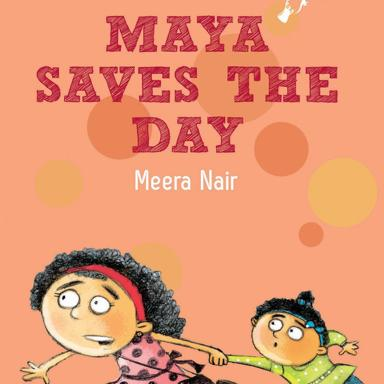What emotions do the characters on the book cover seem to be expressing, and how does that tie into the possible theme of the book? The older girl appears to be looking ahead with determination and a hint of concern, possibly indicating her role as a protagonist who faces challenges head-on. The younger child seems to be partly surprised and excited, perhaps due to the unexpected adventure. These expressions suggest themes of bravery, responsibility, and adventure, which are common in children's literature aimed at teaching valuable lessons through engaging stories. 